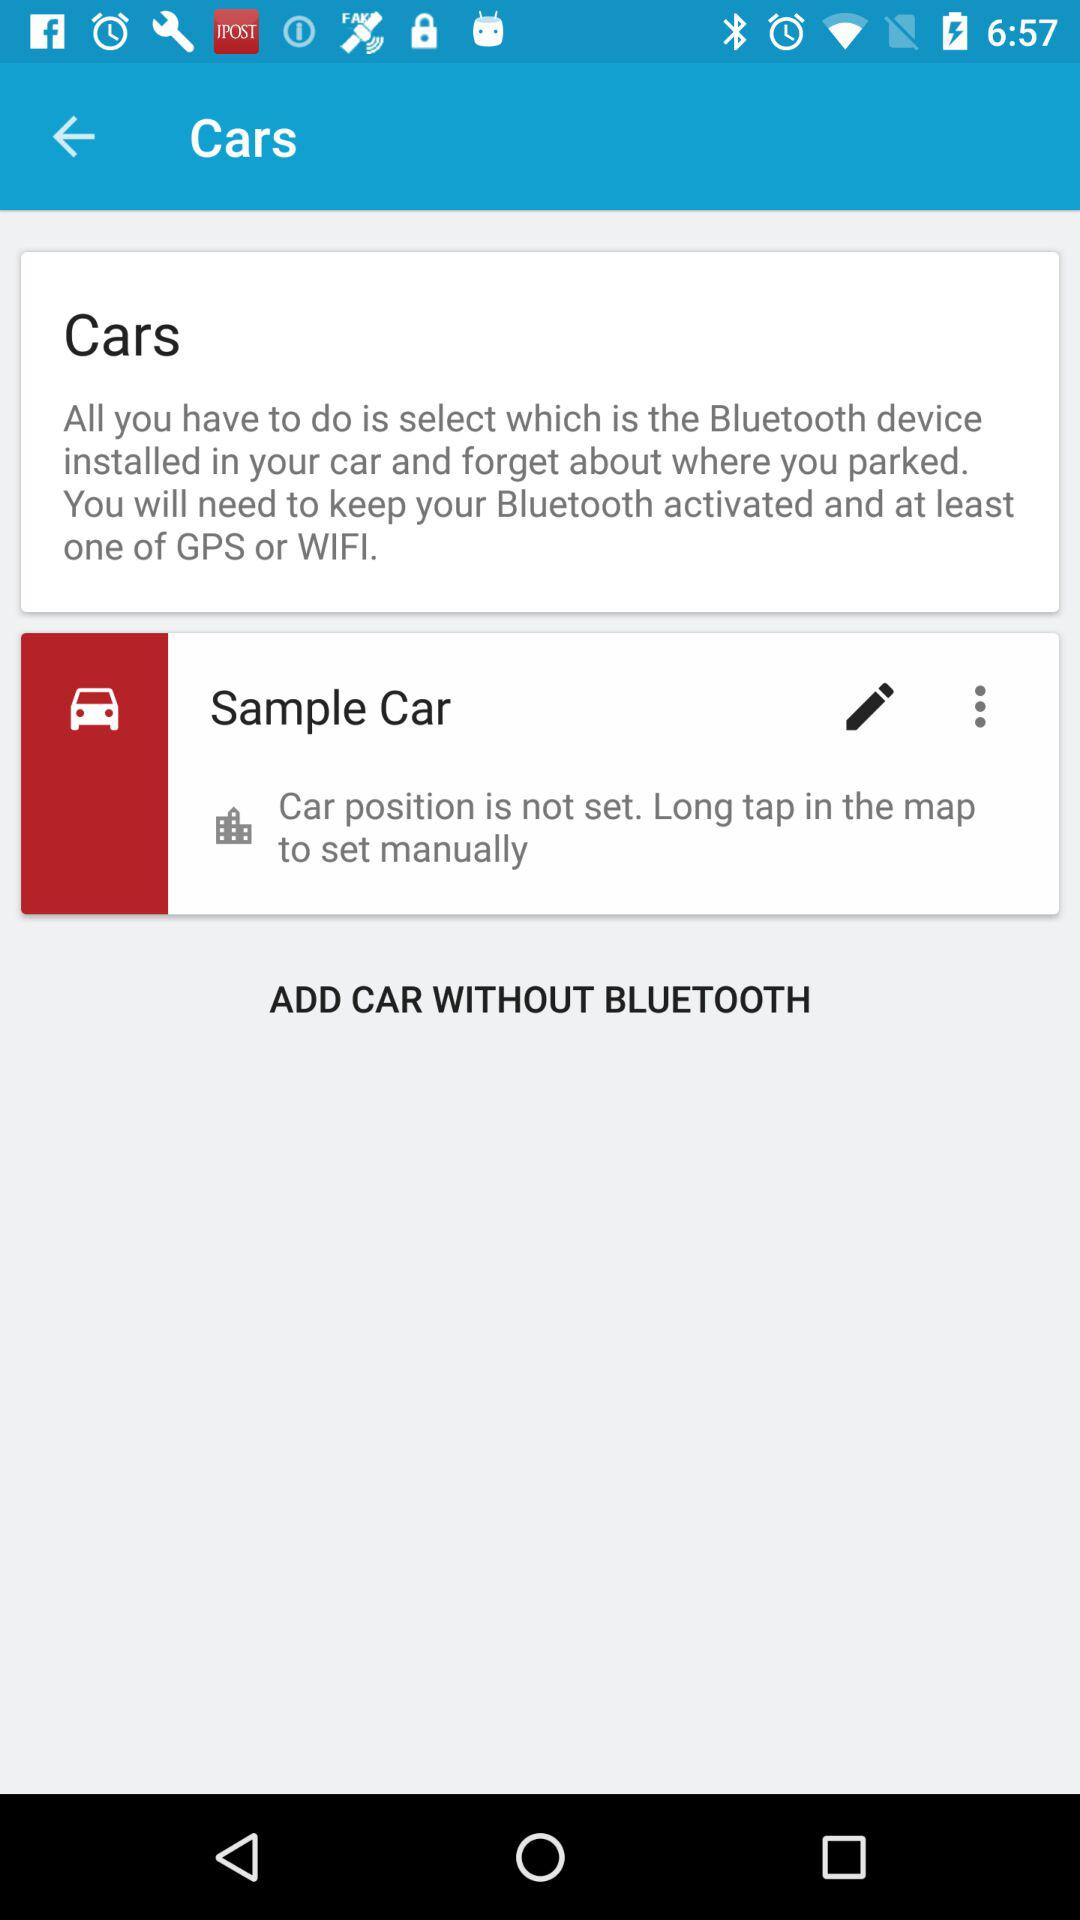Can we add car without bluetooth?
When the provided information is insufficient, respond with <no answer>. <no answer> 